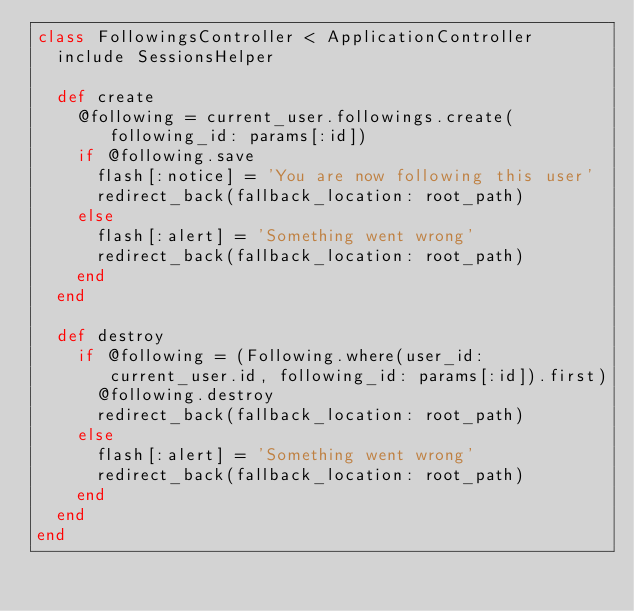<code> <loc_0><loc_0><loc_500><loc_500><_Ruby_>class FollowingsController < ApplicationController
  include SessionsHelper

  def create
    @following = current_user.followings.create(following_id: params[:id])
    if @following.save
      flash[:notice] = 'You are now following this user'
      redirect_back(fallback_location: root_path)
    else
      flash[:alert] = 'Something went wrong'
      redirect_back(fallback_location: root_path)
    end
  end

  def destroy
    if @following = (Following.where(user_id: current_user.id, following_id: params[:id]).first)
      @following.destroy
      redirect_back(fallback_location: root_path)
    else
      flash[:alert] = 'Something went wrong'
      redirect_back(fallback_location: root_path)
    end
  end
end
</code> 